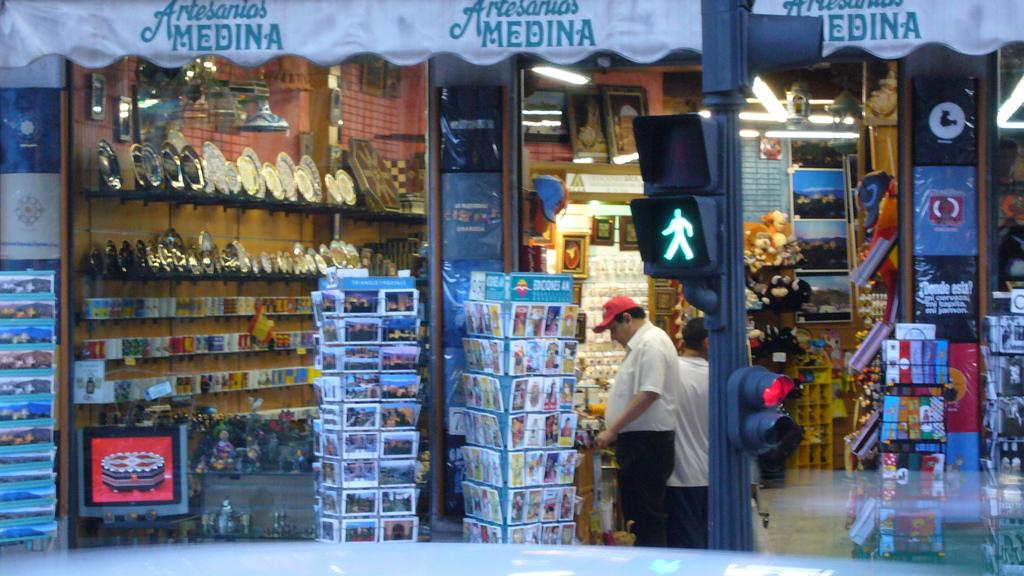Is this the medina store?
Keep it short and to the point. Yes. 